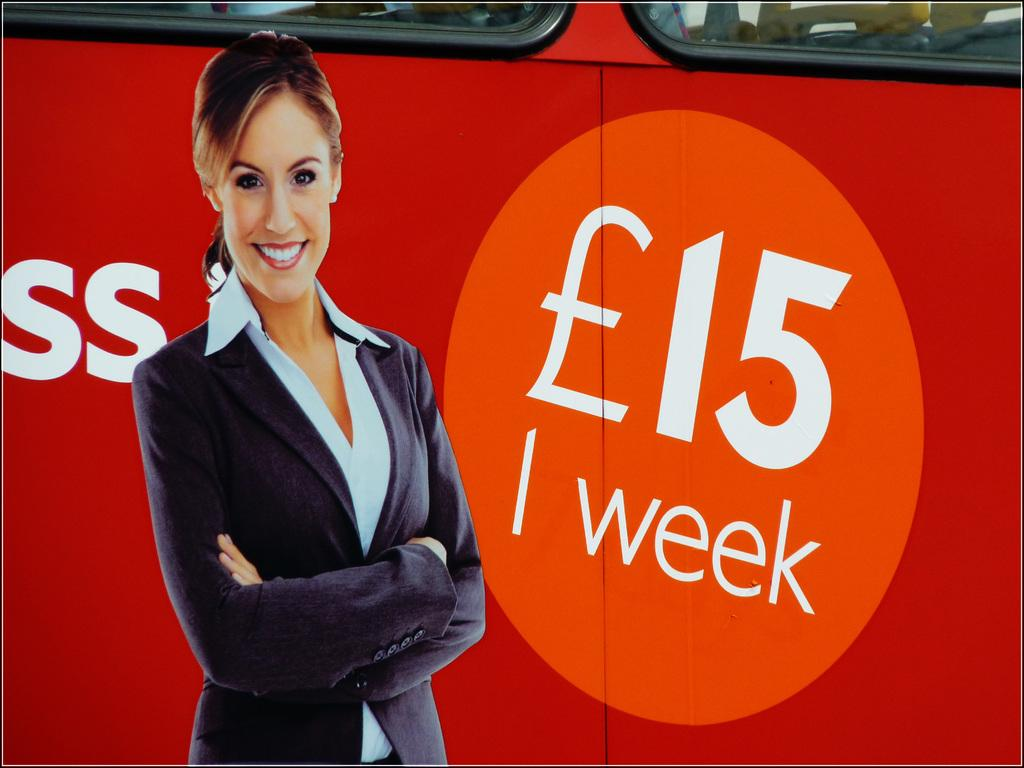Who is the main subject in the image? There is a lady in the image. What is the lady doing in the image? The lady is standing and smiling. What can be seen in the background of the image? There is a vehicle in the background of the image. How many balloons are tied to the lady's boot in the image? There are no balloons or boots present in the image, so this question cannot be answered. 